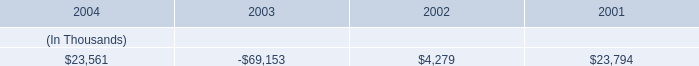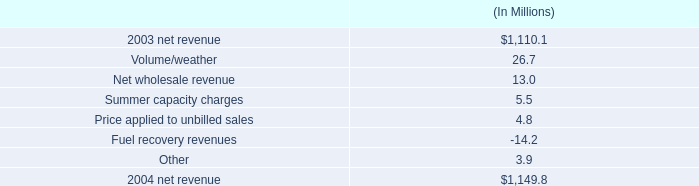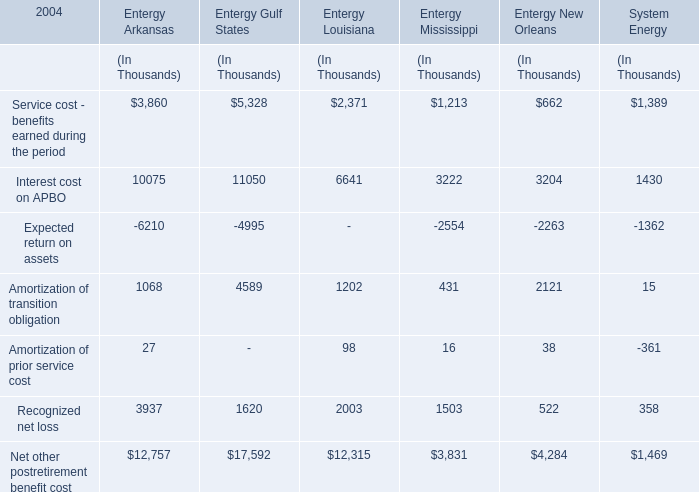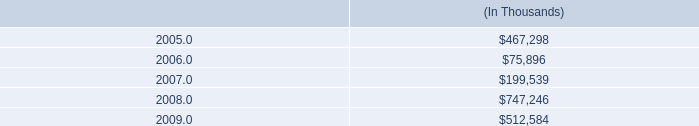what are the provisions for potential rate refunds as a percentage of net revenue in 2004? 
Computations: (22.6 / 1149.8)
Answer: 0.01966. 